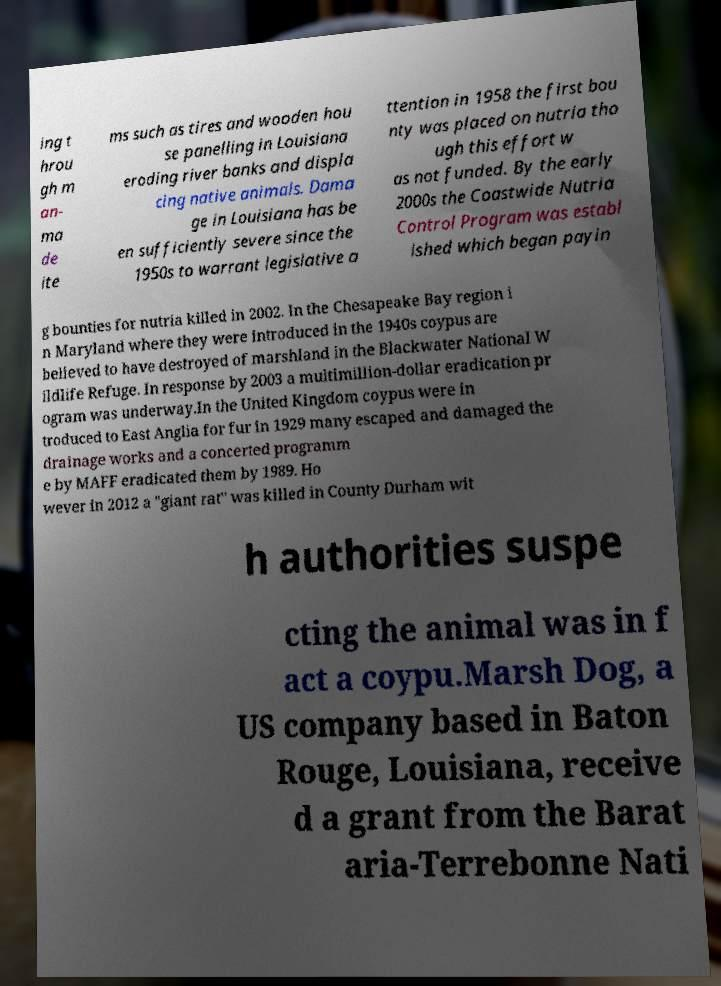What messages or text are displayed in this image? I need them in a readable, typed format. ing t hrou gh m an- ma de ite ms such as tires and wooden hou se panelling in Louisiana eroding river banks and displa cing native animals. Dama ge in Louisiana has be en sufficiently severe since the 1950s to warrant legislative a ttention in 1958 the first bou nty was placed on nutria tho ugh this effort w as not funded. By the early 2000s the Coastwide Nutria Control Program was establ ished which began payin g bounties for nutria killed in 2002. In the Chesapeake Bay region i n Maryland where they were introduced in the 1940s coypus are believed to have destroyed of marshland in the Blackwater National W ildlife Refuge. In response by 2003 a multimillion-dollar eradication pr ogram was underway.In the United Kingdom coypus were in troduced to East Anglia for fur in 1929 many escaped and damaged the drainage works and a concerted programm e by MAFF eradicated them by 1989. Ho wever in 2012 a "giant rat" was killed in County Durham wit h authorities suspe cting the animal was in f act a coypu.Marsh Dog, a US company based in Baton Rouge, Louisiana, receive d a grant from the Barat aria-Terrebonne Nati 